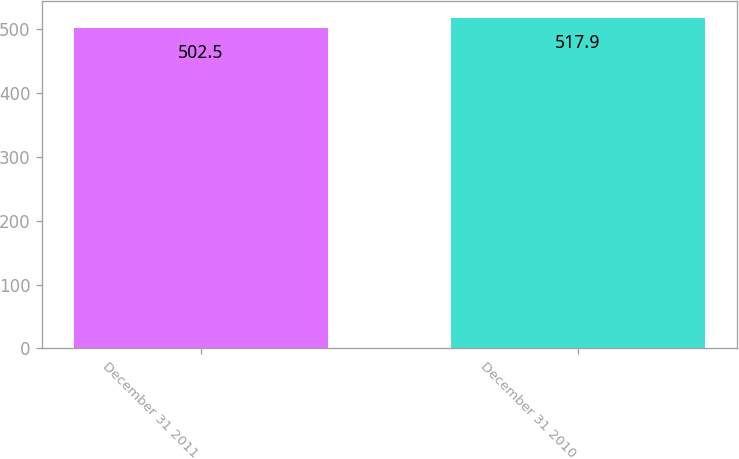Convert chart to OTSL. <chart><loc_0><loc_0><loc_500><loc_500><bar_chart><fcel>December 31 2011<fcel>December 31 2010<nl><fcel>502.5<fcel>517.9<nl></chart> 